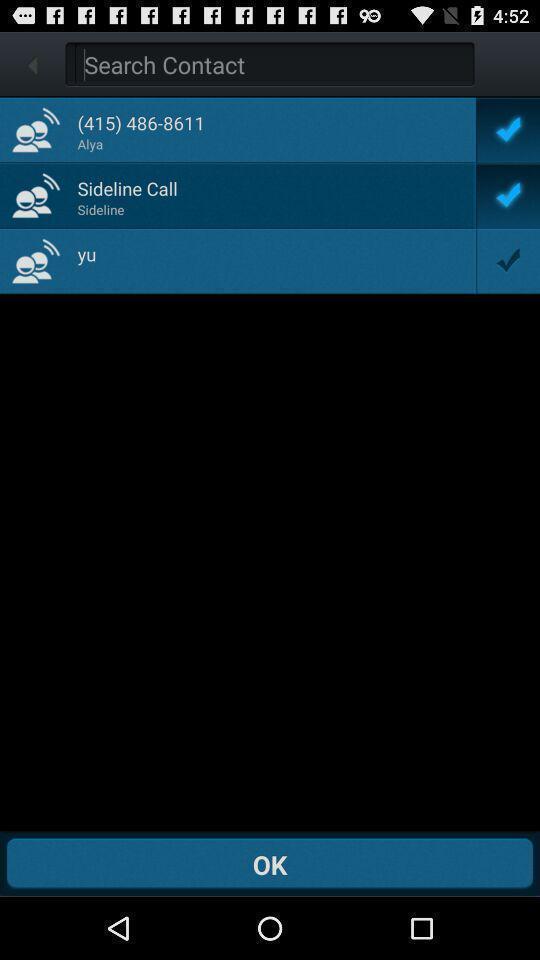Provide a description of this screenshot. Window displaying the contacts page. 